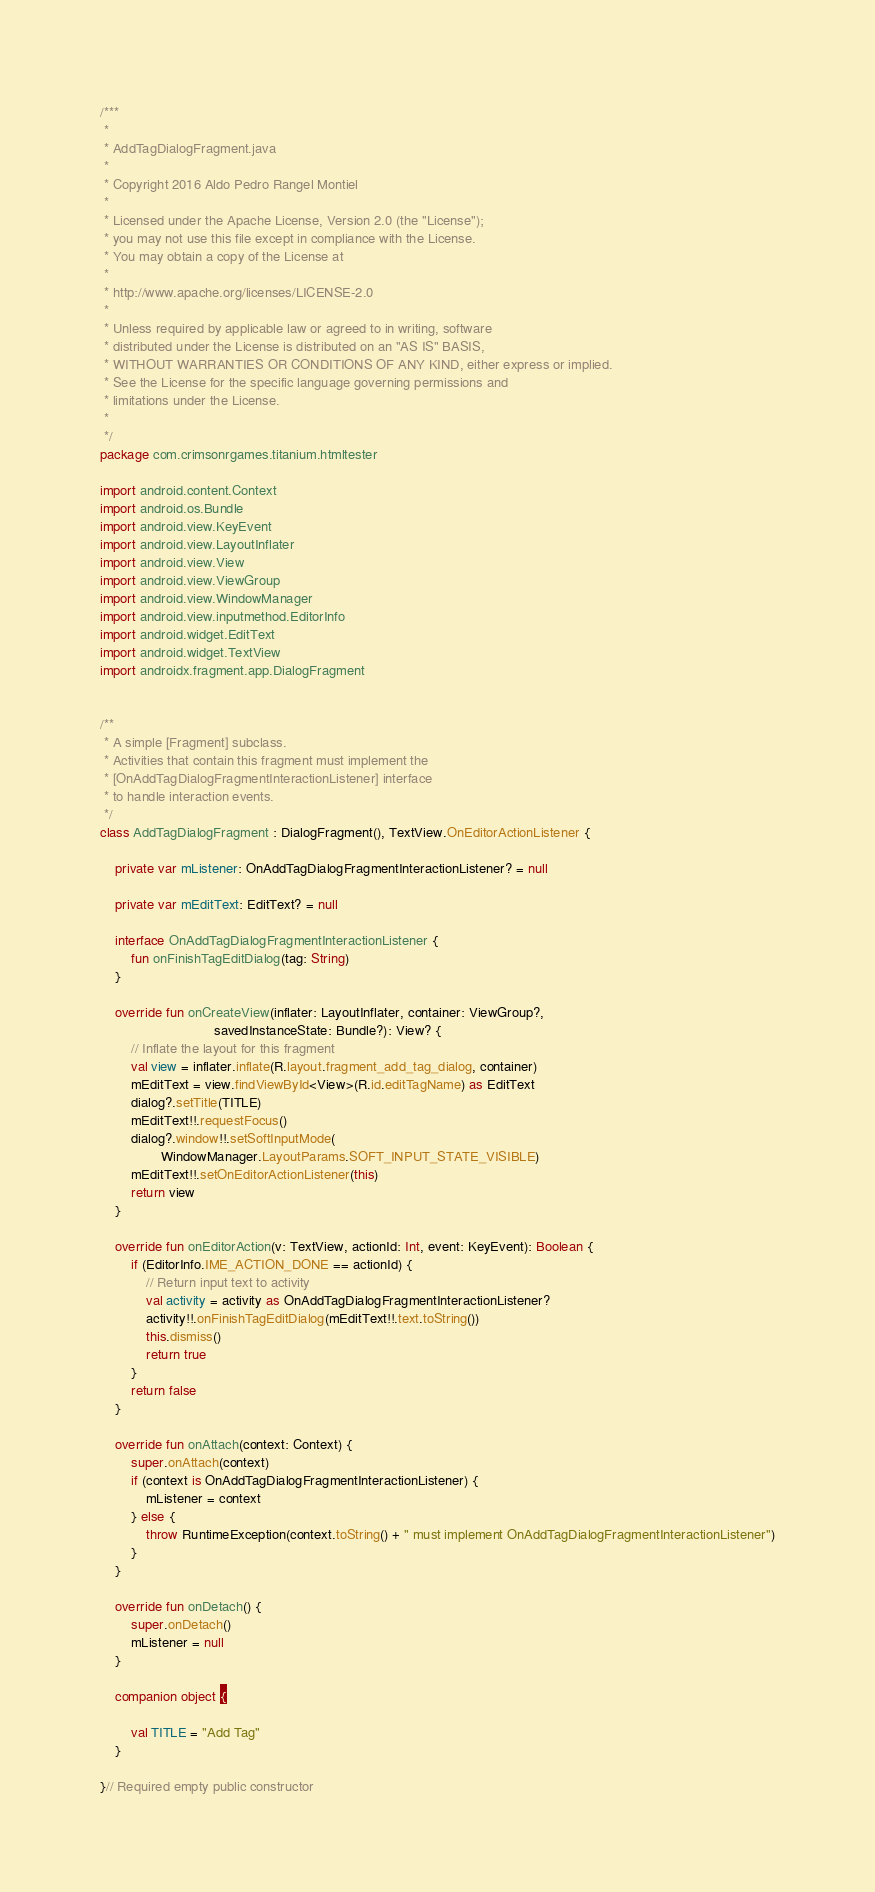Convert code to text. <code><loc_0><loc_0><loc_500><loc_500><_Kotlin_>/***
 *
 * AddTagDialogFragment.java
 *
 * Copyright 2016 Aldo Pedro Rangel Montiel
 *
 * Licensed under the Apache License, Version 2.0 (the "License");
 * you may not use this file except in compliance with the License.
 * You may obtain a copy of the License at
 *
 * http://www.apache.org/licenses/LICENSE-2.0
 *
 * Unless required by applicable law or agreed to in writing, software
 * distributed under the License is distributed on an "AS IS" BASIS,
 * WITHOUT WARRANTIES OR CONDITIONS OF ANY KIND, either express or implied.
 * See the License for the specific language governing permissions and
 * limitations under the License.
 *
 */
package com.crimsonrgames.titanium.htmltester

import android.content.Context
import android.os.Bundle
import android.view.KeyEvent
import android.view.LayoutInflater
import android.view.View
import android.view.ViewGroup
import android.view.WindowManager
import android.view.inputmethod.EditorInfo
import android.widget.EditText
import android.widget.TextView
import androidx.fragment.app.DialogFragment


/**
 * A simple [Fragment] subclass.
 * Activities that contain this fragment must implement the
 * [OnAddTagDialogFragmentInteractionListener] interface
 * to handle interaction events.
 */
class AddTagDialogFragment : DialogFragment(), TextView.OnEditorActionListener {

    private var mListener: OnAddTagDialogFragmentInteractionListener? = null

    private var mEditText: EditText? = null

    interface OnAddTagDialogFragmentInteractionListener {
        fun onFinishTagEditDialog(tag: String)
    }

    override fun onCreateView(inflater: LayoutInflater, container: ViewGroup?,
                              savedInstanceState: Bundle?): View? {
        // Inflate the layout for this fragment
        val view = inflater.inflate(R.layout.fragment_add_tag_dialog, container)
        mEditText = view.findViewById<View>(R.id.editTagName) as EditText
        dialog?.setTitle(TITLE)
        mEditText!!.requestFocus()
        dialog?.window!!.setSoftInputMode(
                WindowManager.LayoutParams.SOFT_INPUT_STATE_VISIBLE)
        mEditText!!.setOnEditorActionListener(this)
        return view
    }

    override fun onEditorAction(v: TextView, actionId: Int, event: KeyEvent): Boolean {
        if (EditorInfo.IME_ACTION_DONE == actionId) {
            // Return input text to activity
            val activity = activity as OnAddTagDialogFragmentInteractionListener?
            activity!!.onFinishTagEditDialog(mEditText!!.text.toString())
            this.dismiss()
            return true
        }
        return false
    }

    override fun onAttach(context: Context) {
        super.onAttach(context)
        if (context is OnAddTagDialogFragmentInteractionListener) {
            mListener = context
        } else {
            throw RuntimeException(context.toString() + " must implement OnAddTagDialogFragmentInteractionListener")
        }
    }

    override fun onDetach() {
        super.onDetach()
        mListener = null
    }

    companion object {

        val TITLE = "Add Tag"
    }

}// Required empty public constructor
</code> 